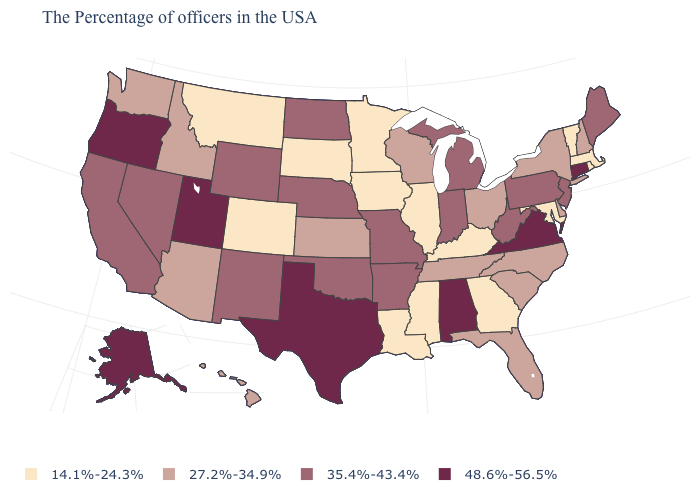What is the value of New Jersey?
Concise answer only. 35.4%-43.4%. Is the legend a continuous bar?
Write a very short answer. No. Does the map have missing data?
Give a very brief answer. No. What is the value of Rhode Island?
Concise answer only. 14.1%-24.3%. What is the lowest value in the USA?
Concise answer only. 14.1%-24.3%. Name the states that have a value in the range 48.6%-56.5%?
Answer briefly. Connecticut, Virginia, Alabama, Texas, Utah, Oregon, Alaska. Does Utah have the highest value in the USA?
Write a very short answer. Yes. What is the highest value in the Northeast ?
Be succinct. 48.6%-56.5%. Does Tennessee have the highest value in the South?
Concise answer only. No. Name the states that have a value in the range 14.1%-24.3%?
Quick response, please. Massachusetts, Rhode Island, Vermont, Maryland, Georgia, Kentucky, Illinois, Mississippi, Louisiana, Minnesota, Iowa, South Dakota, Colorado, Montana. What is the highest value in the Northeast ?
Be succinct. 48.6%-56.5%. What is the lowest value in the USA?
Answer briefly. 14.1%-24.3%. Which states have the highest value in the USA?
Answer briefly. Connecticut, Virginia, Alabama, Texas, Utah, Oregon, Alaska. Does New York have the lowest value in the USA?
Answer briefly. No. What is the value of Delaware?
Quick response, please. 27.2%-34.9%. 